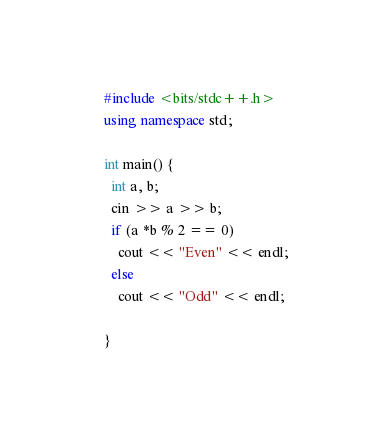<code> <loc_0><loc_0><loc_500><loc_500><_C++_>#include <bits/stdc++.h>
using namespace std;

int main() {
  int a, b;
  cin >> a >> b;
  if (a *b % 2 == 0)
    cout << "Even" << endl;
  else 
    cout << "Odd" << endl;
  
}

</code> 